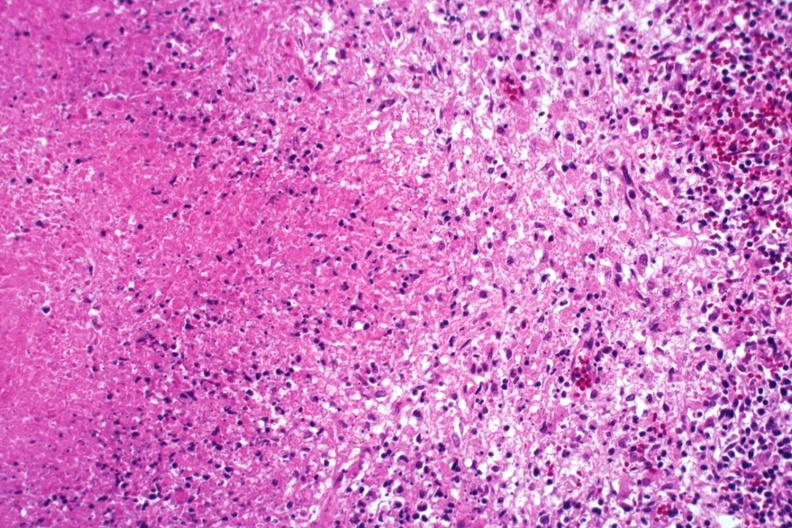s this image shows of smooth muscle cell with lipid in sarcoplasm and lipid present?
Answer the question using a single word or phrase. No 